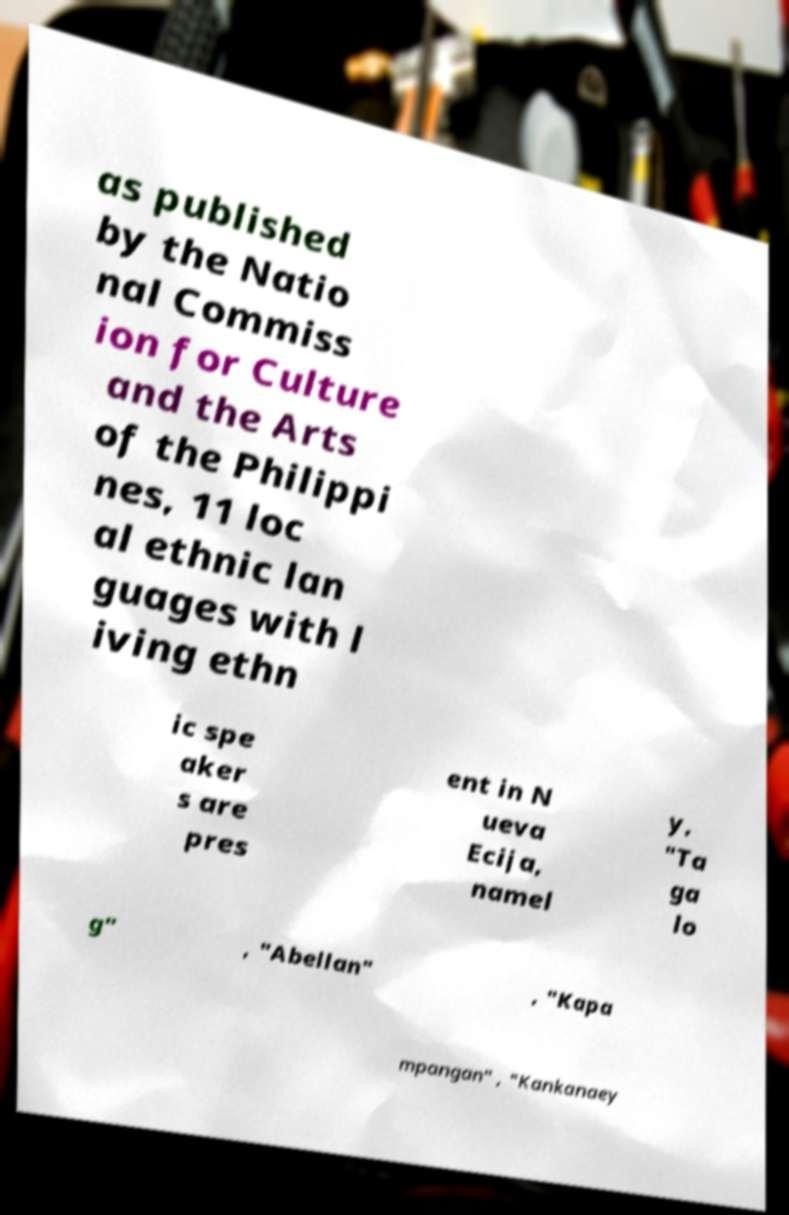For documentation purposes, I need the text within this image transcribed. Could you provide that? as published by the Natio nal Commiss ion for Culture and the Arts of the Philippi nes, 11 loc al ethnic lan guages with l iving ethn ic spe aker s are pres ent in N ueva Ecija, namel y, "Ta ga lo g" , "Abellan" , "Kapa mpangan" , "Kankanaey 